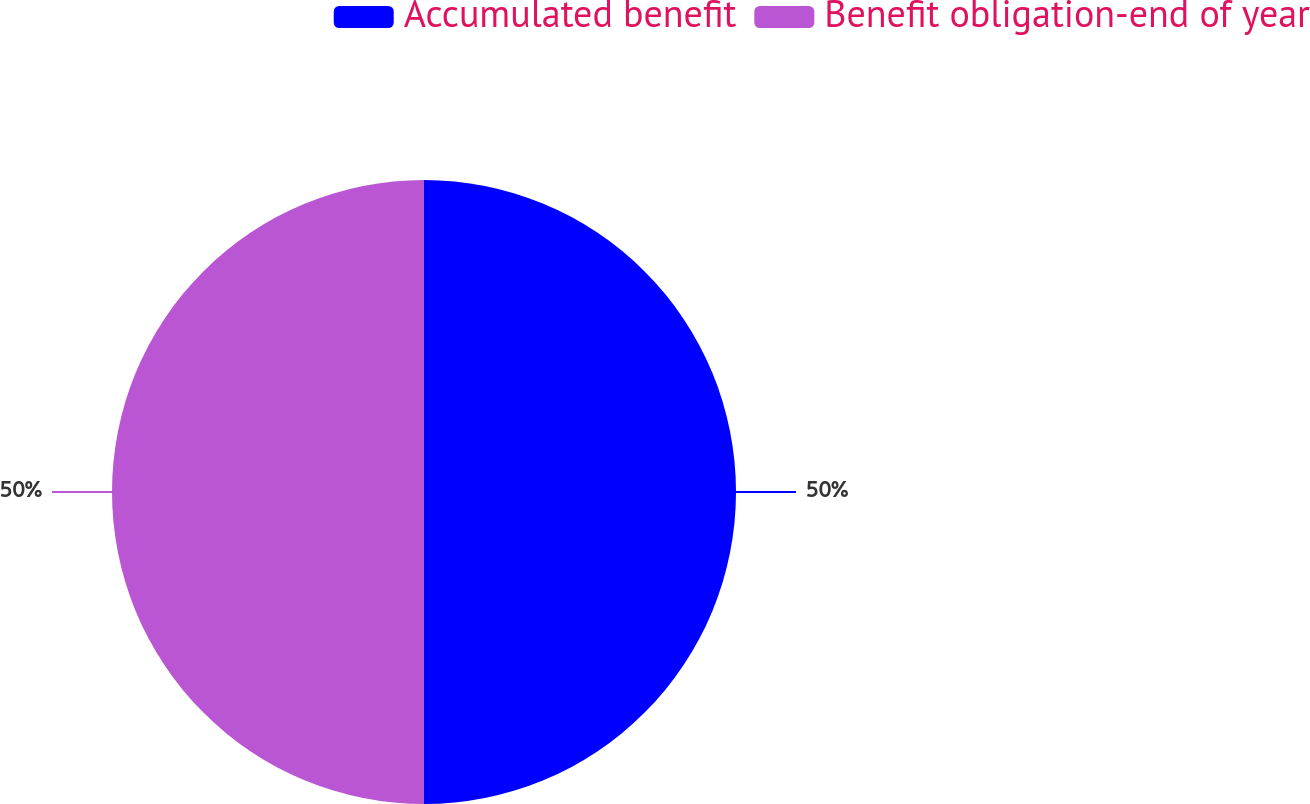Convert chart. <chart><loc_0><loc_0><loc_500><loc_500><pie_chart><fcel>Accumulated benefit<fcel>Benefit obligation-end of year<nl><fcel>50.0%<fcel>50.0%<nl></chart> 